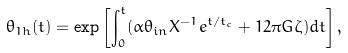<formula> <loc_0><loc_0><loc_500><loc_500>\theta _ { 1 h } ( t ) = \exp \left [ \int _ { 0 } ^ { t } ( \alpha \theta _ { i n } X ^ { - 1 } e ^ { t / t _ { c } } + 1 2 \pi G \zeta ) d t \right ] ,</formula> 